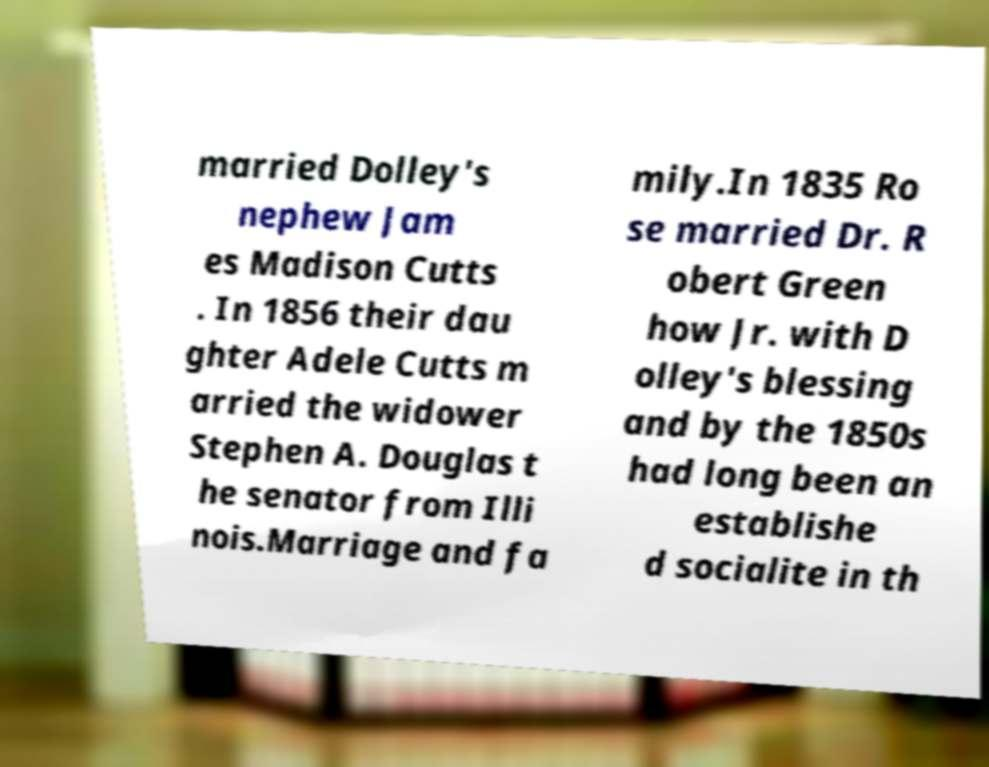Could you assist in decoding the text presented in this image and type it out clearly? married Dolley's nephew Jam es Madison Cutts . In 1856 their dau ghter Adele Cutts m arried the widower Stephen A. Douglas t he senator from Illi nois.Marriage and fa mily.In 1835 Ro se married Dr. R obert Green how Jr. with D olley's blessing and by the 1850s had long been an establishe d socialite in th 